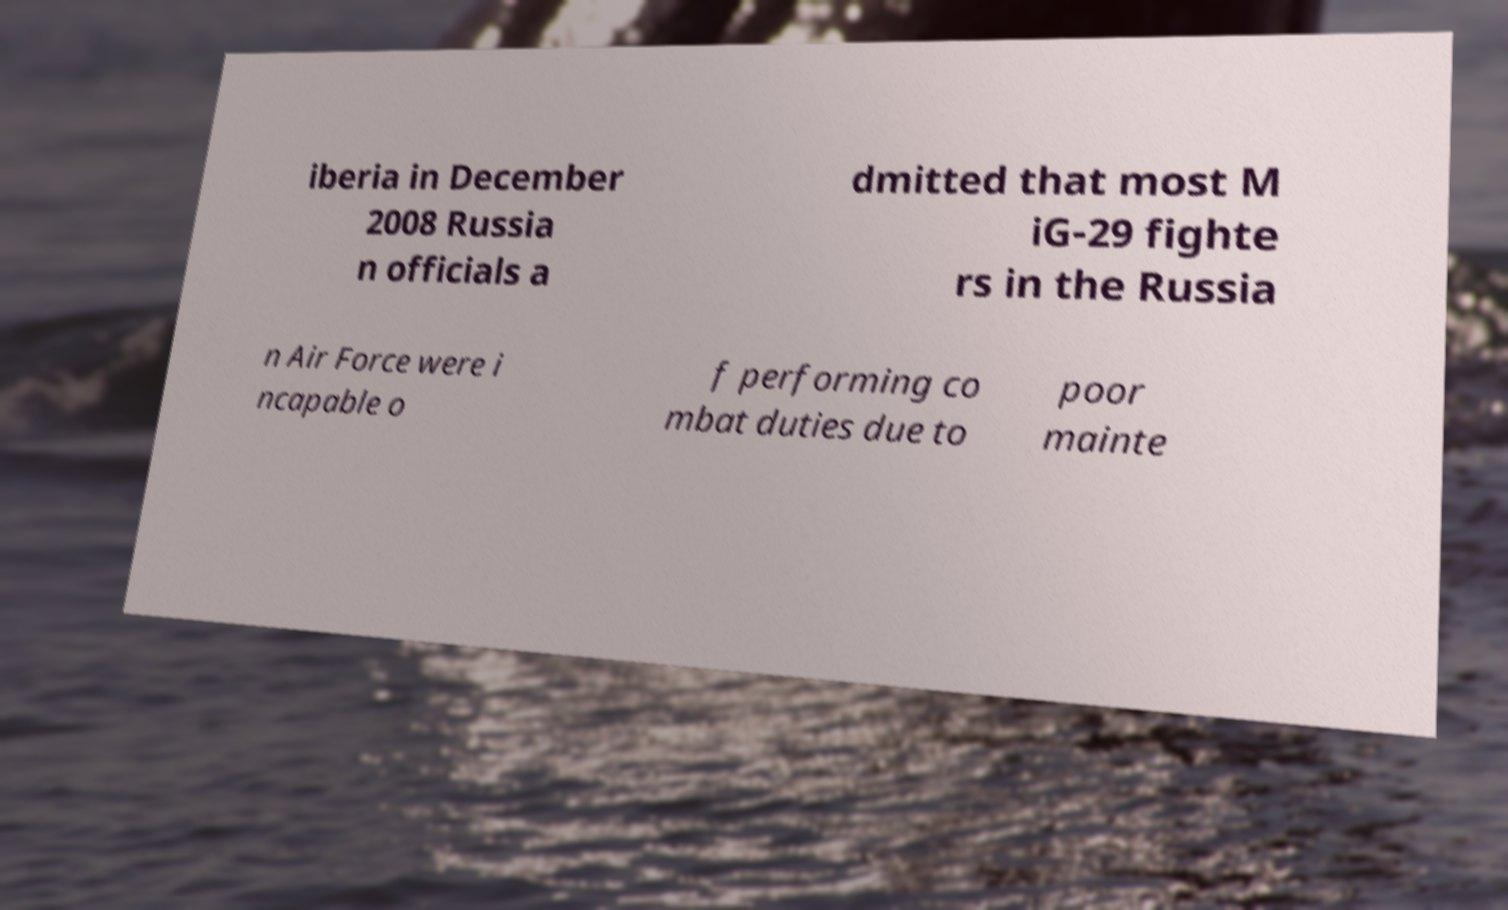Can you accurately transcribe the text from the provided image for me? iberia in December 2008 Russia n officials a dmitted that most M iG-29 fighte rs in the Russia n Air Force were i ncapable o f performing co mbat duties due to poor mainte 